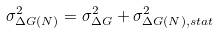<formula> <loc_0><loc_0><loc_500><loc_500>\sigma ^ { 2 } _ { \Delta G ( N ) } = \sigma ^ { 2 } _ { \Delta G } + \sigma ^ { 2 } _ { \Delta G ( N ) , s t a t }</formula> 